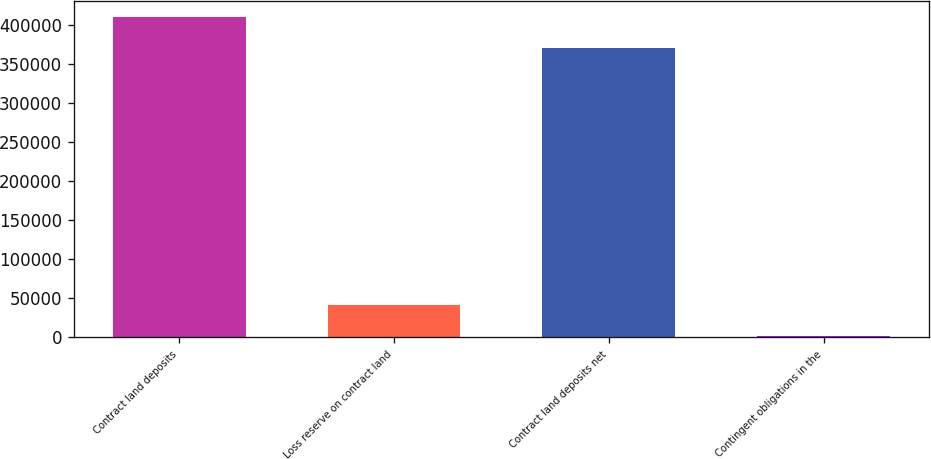<chart> <loc_0><loc_0><loc_500><loc_500><bar_chart><fcel>Contract land deposits<fcel>Loss reserve on contract land<fcel>Contract land deposits net<fcel>Contingent obligations in the<nl><fcel>410272<fcel>41839.2<fcel>370429<fcel>1996<nl></chart> 